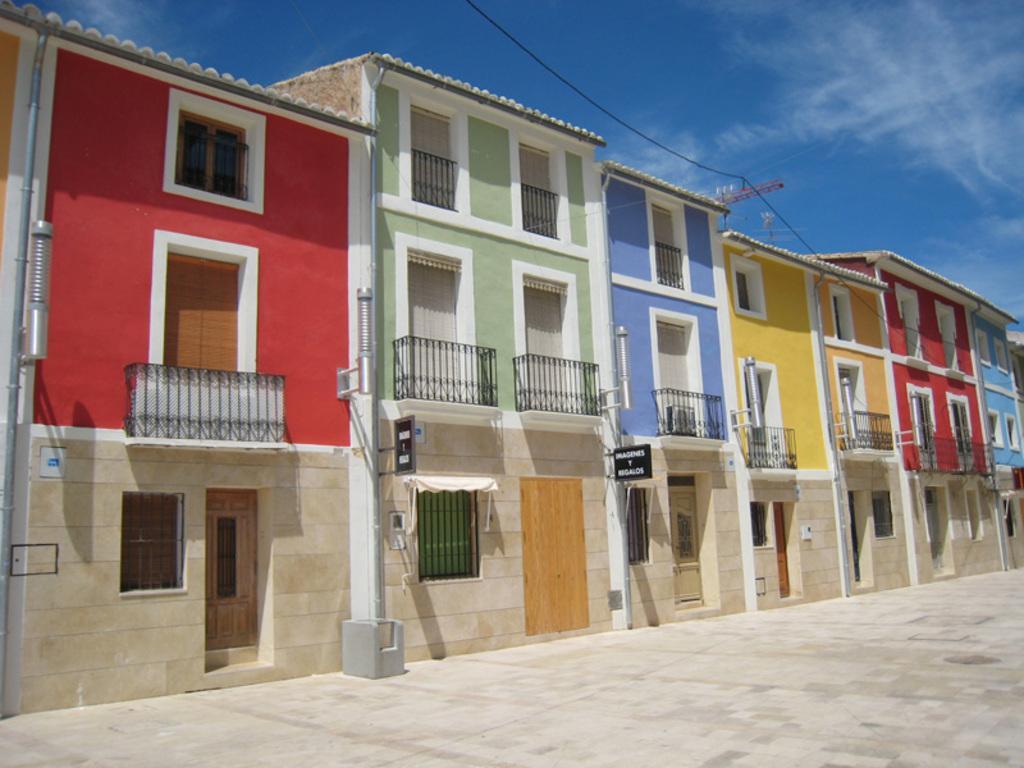Describe this image in one or two sentences. In this image we can see buildings with windows, railings and doors. Also there are boards with names. In the background there is sky with clouds. 